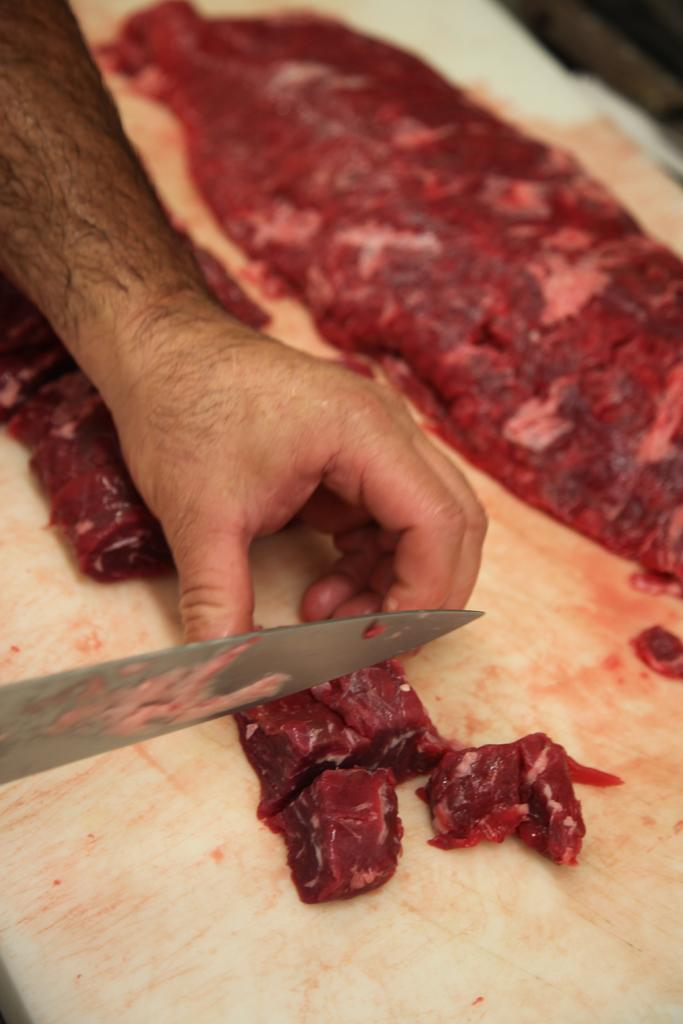What body part is visible in the image? A person's hand is visible in the image. What is the person holding in their hand? The person is holding a knife. What is the knife being used for? The knife is being used to cut meat into pieces. What is at the bottom of the image? There is a board at the bottom of the image. What type of umbrella is being used to protect the meat from the rain in the image? There is no umbrella present in the image, and the meat is not being protected from the rain. 